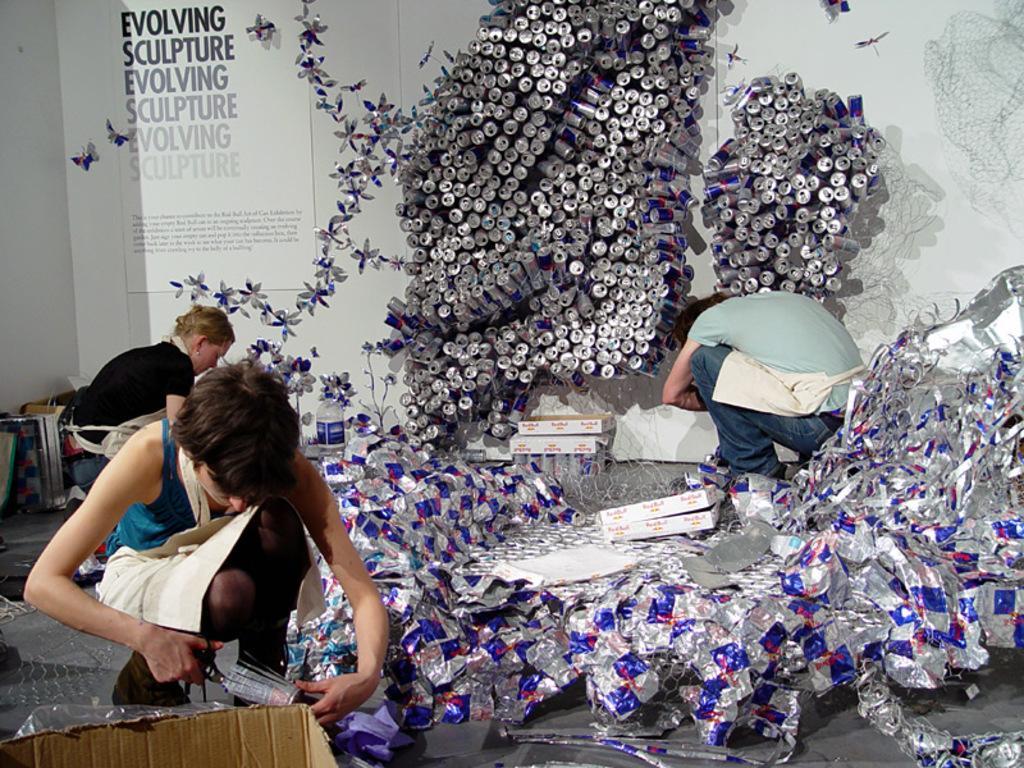Could you give a brief overview of what you see in this image? In this image, there are a few people. We can see the wall with some architecture. We can also see some coke tins. We can see a board with some text written. We can see the ground with some objects and cardboard box. 